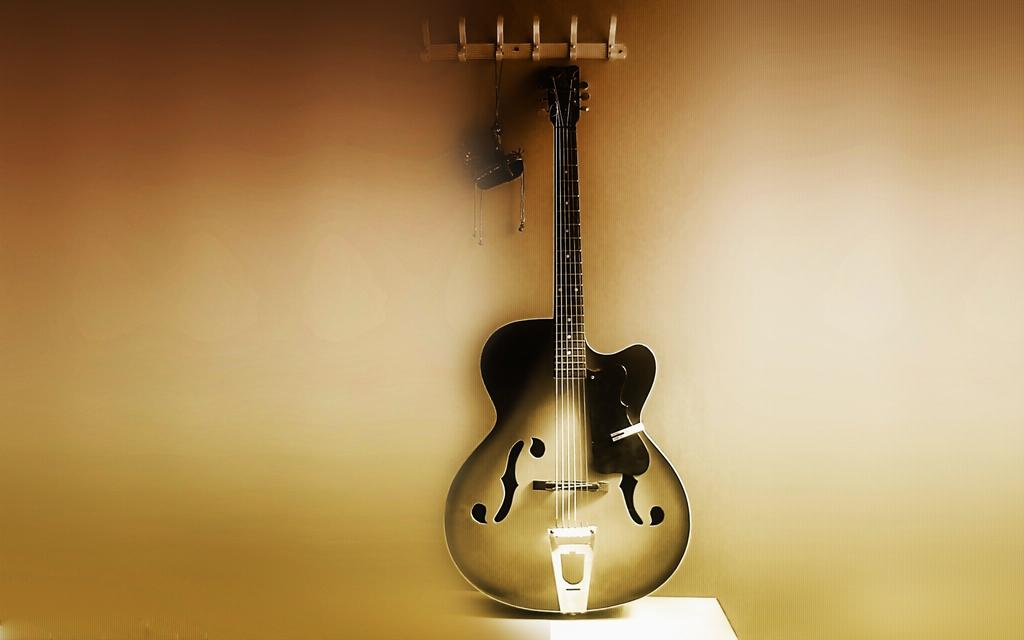What is the main subject of the image? There is a guitar in the center of the image. What can be seen in the background of the image? There is a wall in the background of the image. Is there anything hanging on the wall in the background? Yes, there is an object hanging in the background of the image. How does the guitar express its feelings in the image? The guitar is an inanimate object and does not have feelings. --- 